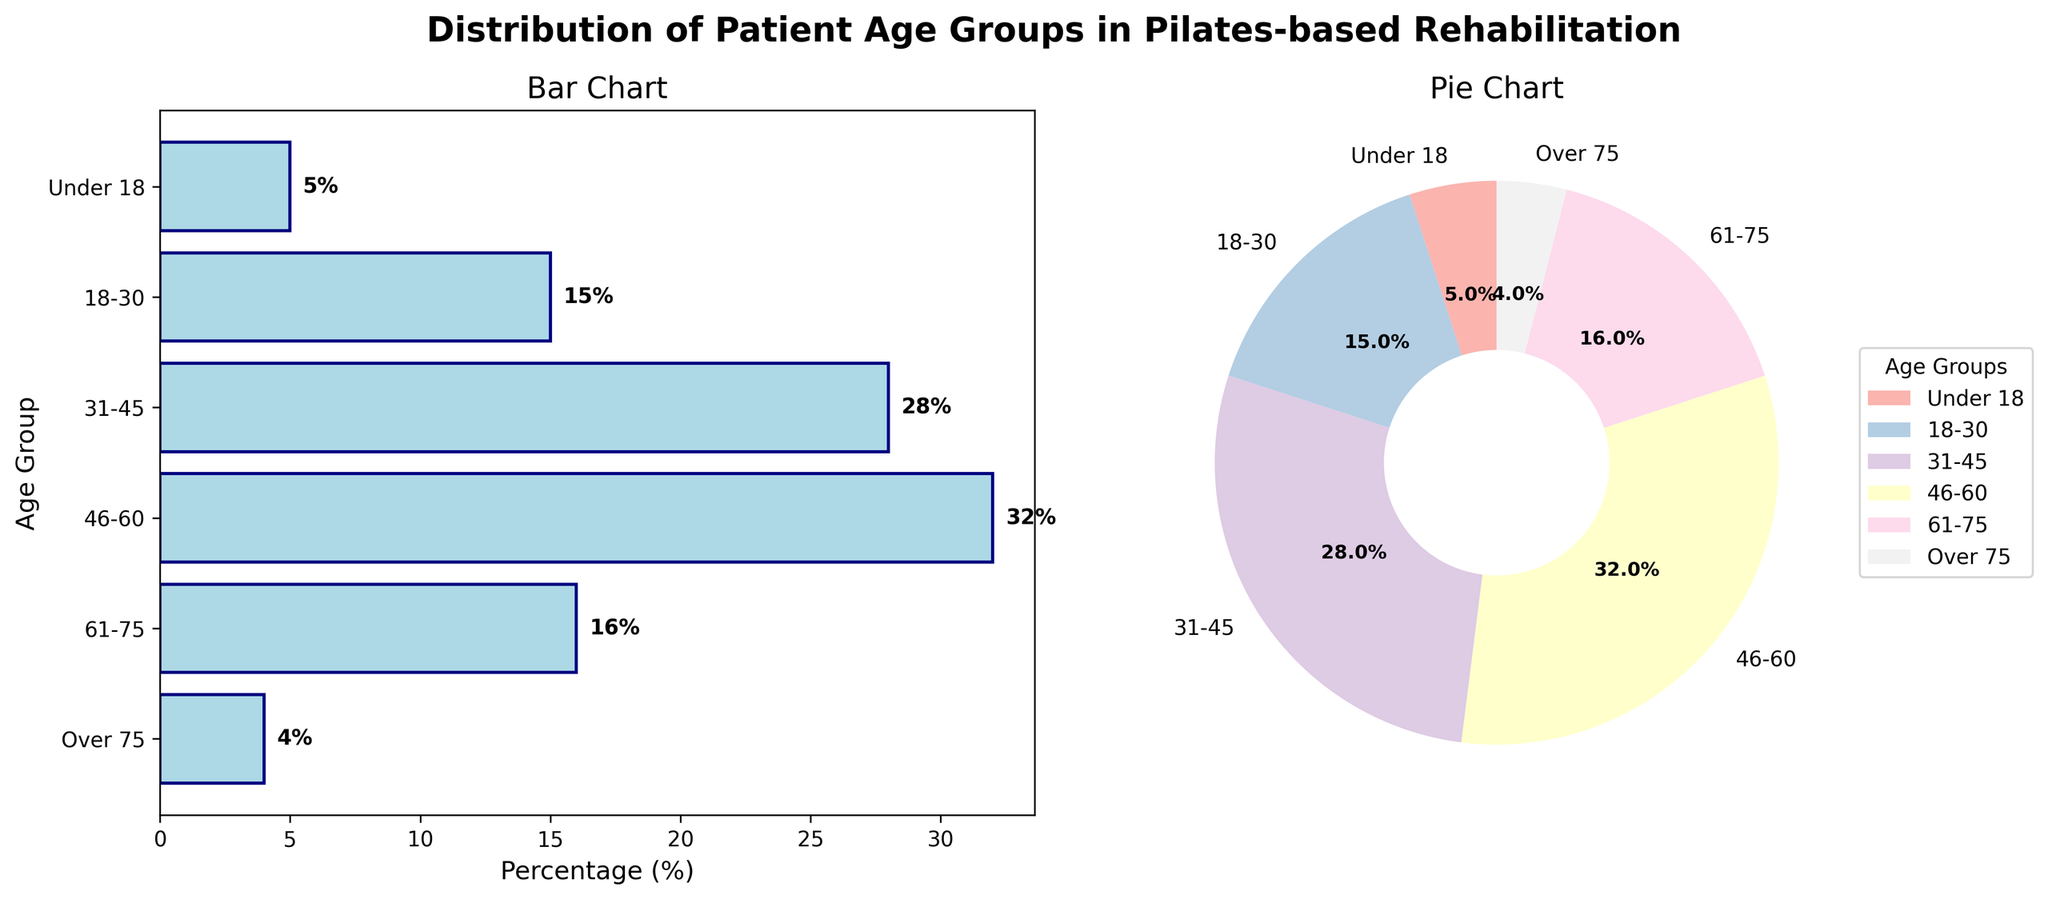what is the age group title displayed in the plot? The title of the plot is at the top center of the figure. It reads "Distribution of Patient Age Groups in Pilates-based Rehabilitation."
Answer: Distribution of Patient Age Groups in Pilates-based Rehabilitation Which age group has the highest percentage? In the bar chart on the left, the longest bar represents the age group with the highest percentage. The "46-60" age group has the longest bar with 32%.
Answer: 46-60 What's the width of the bars in the bar chart? The bar chart displays horizontal bars, and their width is given by the percentage values on the x-axis. For instance, the width of the "Under 18" age group bar is 5%.
Answer: Percentage values What color are the bars in the bar chart? All bars in the bar chart are filled with a light blue color and edged with a navy color.
Answer: Light blue with navy edges Which two age groups combined have a percentage closest to 40%? To find the closest 40% combination, add the percentages of various pairs. The sum of the percentages of the "61-75" and "18-30" age groups is 16% + 15% = 31%, which is the closest to 40%.
Answer: 61-75 and 18-30 Which has a higher percentage, the "31-45" age group or the "18-30" age group? In the bar chart, compare the lengths of the bars for the "31-45" and "18-30" age groups. "31-45" has a percentage of 28%, whereas "18-30" has 15%.
Answer: 31-45 Which section of the pie chart covers the smallest angle? The smallest slice of the pie chart represents the age group with the lowest percentage. The "Over 75" age group with 4% covers the smallest angle.
Answer: Over 75 What percentage of patients are under 18? Both the bar chart and pie chart explicitly show percentages for each age group. The percentage for the "Under 18" age group is 5%.
Answer: 5% What is the combined percentage for patients aged 18-60? Add the percentages for the age groups "18-30" (15%), "31-45" (28%), and "46-60" (32%). The sum is 15% + 28% + 32% = 75%.
Answer: 75% How many age groups are shown in the plots? Count the number of distinct age groups listed on the y-axis of the bar chart or the labels in the pie chart. There are 6 distinct age groups: "Under 18," "18-30," "31-45," "46-60," "61-75," and "Over 75."
Answer: 6 